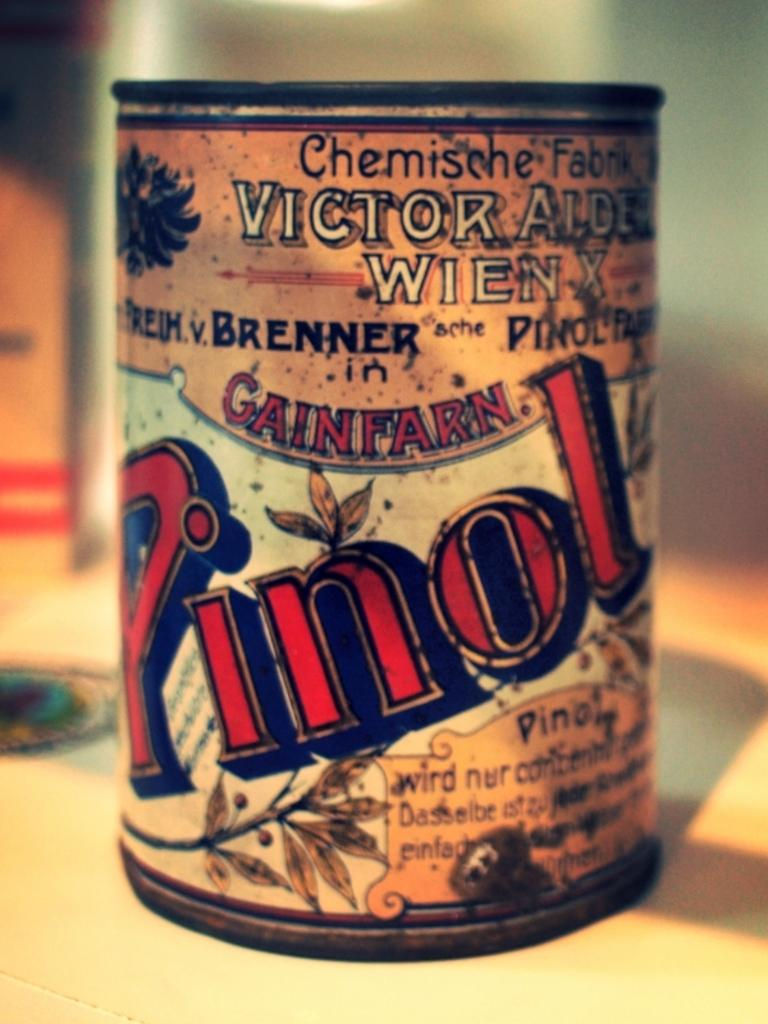<image>
Share a concise interpretation of the image provided. An old looking can with the wor Pinol visible on it. 